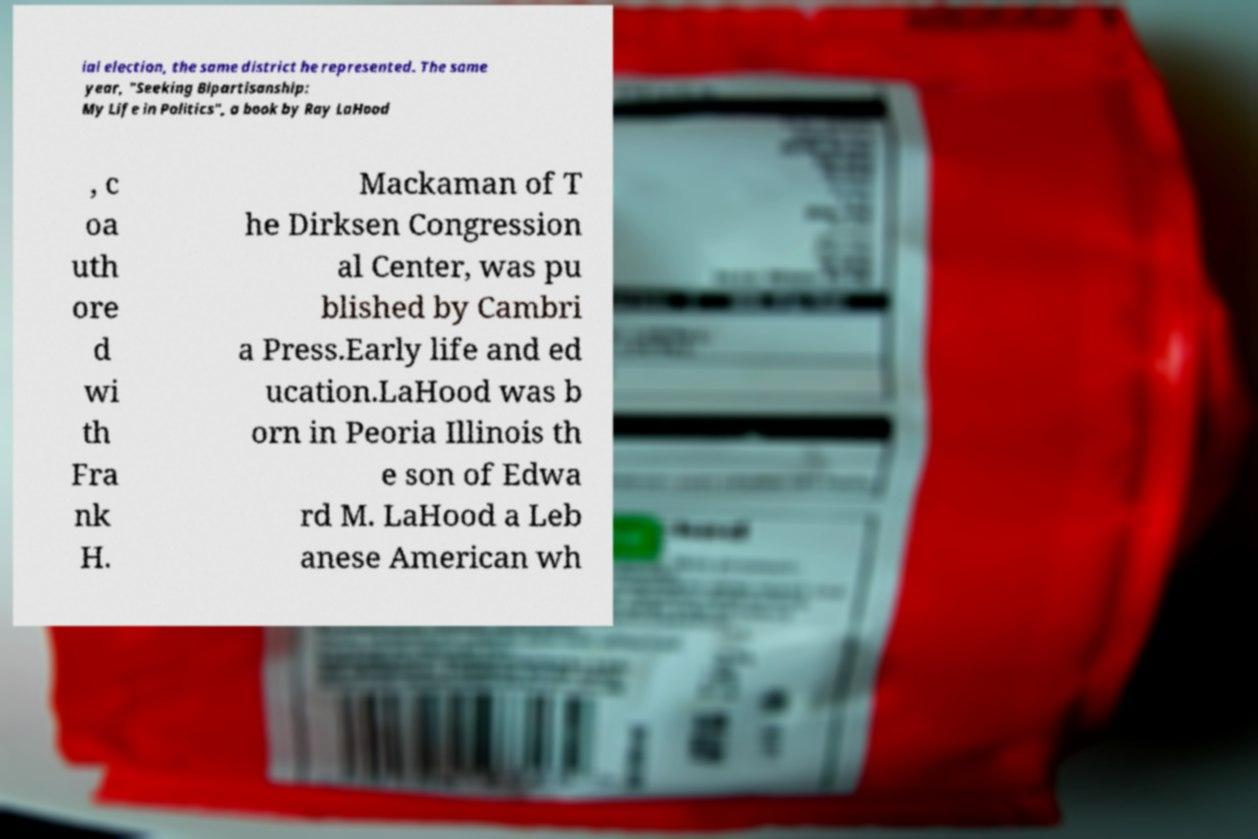What messages or text are displayed in this image? I need them in a readable, typed format. ial election, the same district he represented. The same year, "Seeking Bipartisanship: My Life in Politics", a book by Ray LaHood , c oa uth ore d wi th Fra nk H. Mackaman of T he Dirksen Congression al Center, was pu blished by Cambri a Press.Early life and ed ucation.LaHood was b orn in Peoria Illinois th e son of Edwa rd M. LaHood a Leb anese American wh 